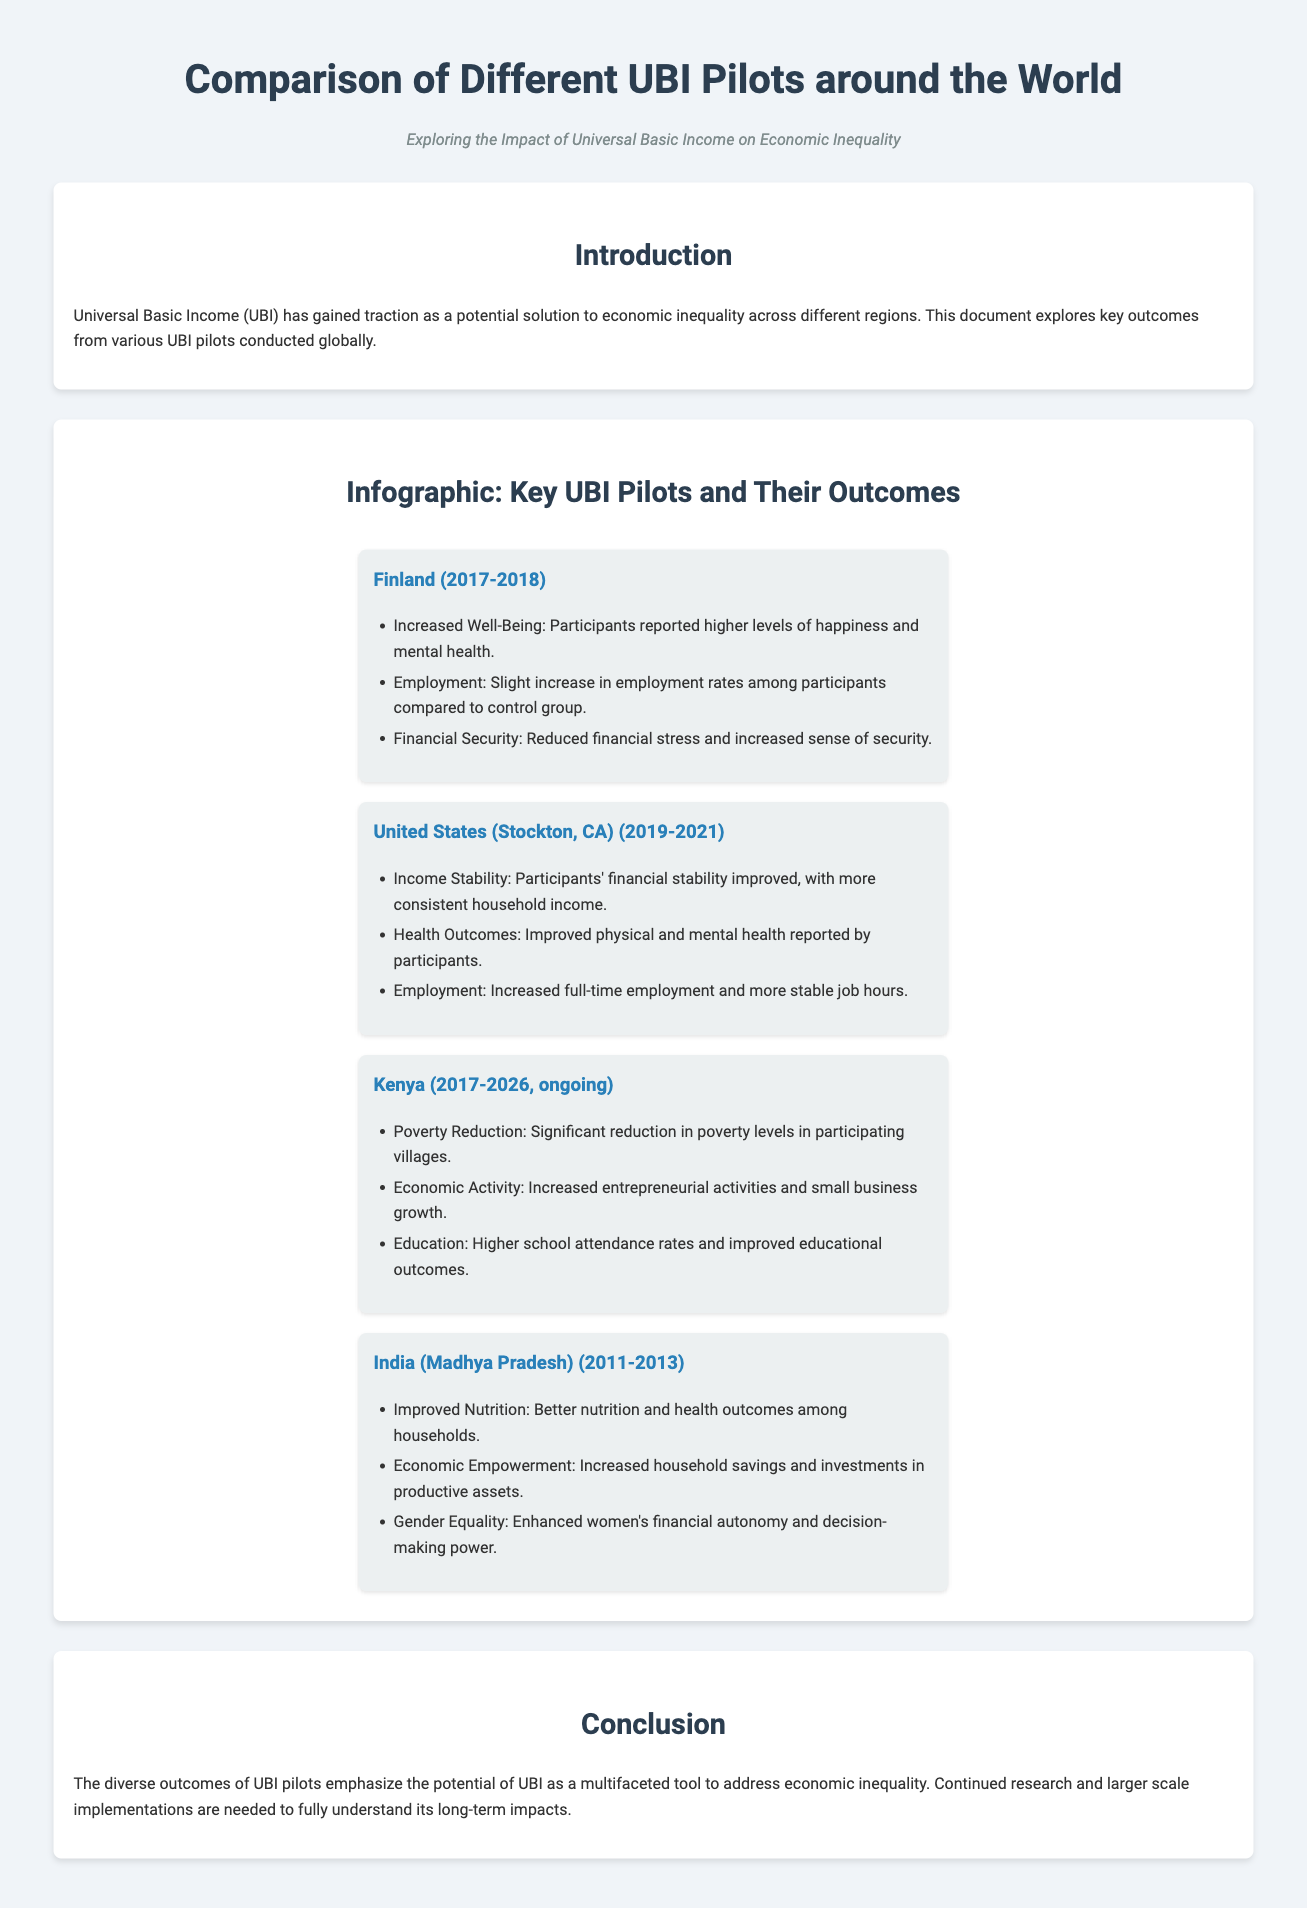what is the title of the document? The title is prominently displayed at the top of the document.
Answer: Comparison of Different UBI Pilots around the World what is the subtitle of the document? The subtitle provides additional context about the document's theme.
Answer: Exploring the Impact of Universal Basic Income on Economic Inequality which country had a UBI pilot from 2017 to 2018? The document lists the countries and their corresponding pilot years.
Answer: Finland what were the key outcomes of the UBI pilot in Kenya? The document summarizes the outcomes for each UBI pilot in a card format.
Answer: Poverty Reduction, Economic Activity, Education how did the UBI pilot in India affect gender equality? One of the outcomes listed for the India pilot addresses women's status.
Answer: Enhanced women's financial autonomy and decision-making power what year did the Stockton, CA UBI pilot begin? The document specifies the years for the UBI pilot in the United States.
Answer: 2019 what type of document is this? This document presents a comparison of UBI pilots and their outcomes.
Answer: Product wrapper how many UBI pilots are mentioned in the document? The document features a section that describes several countries’ UBI pilots.
Answer: Four 